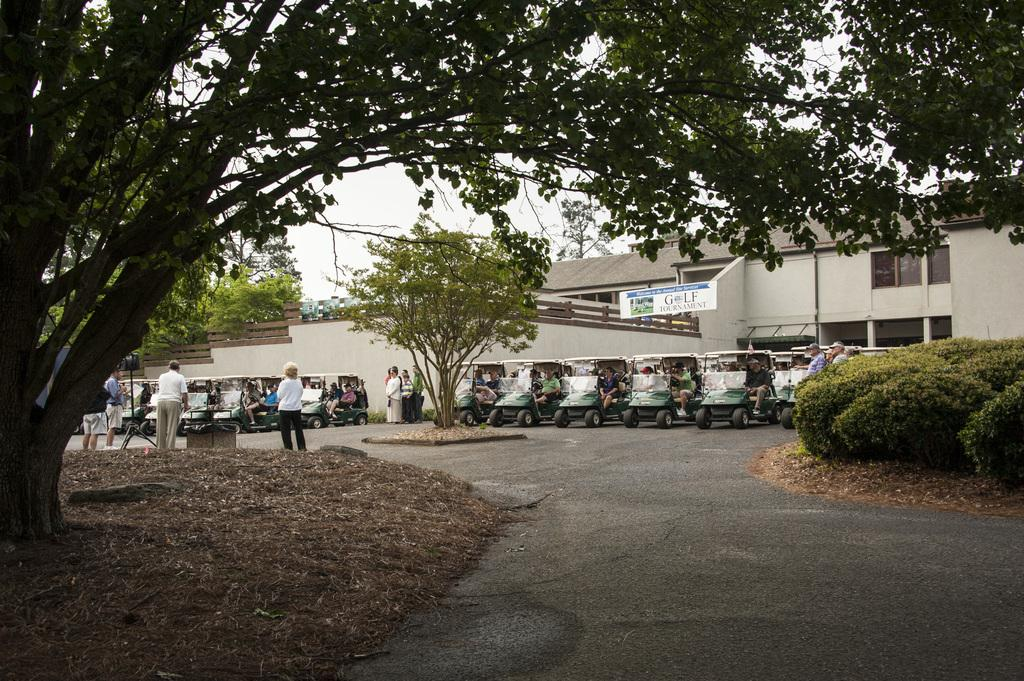What type of vegetation is on the left side of the image? There is a tree on the left side of the image. What type of vegetation is on the right side of the image? There are plants on the right side of the image. What can be seen in the background of the image? In the background of the image, there are people, vehicles, trees, a poster, and a building, as well as the sky. Who is the owner of the day in the image? There is no concept of ownership of a day in the image, as it is a photograph and not a representation of time. Can you see the approval of the poster in the image? The image does not show any indication of approval or disapproval for the poster; it simply displays the poster itself. 